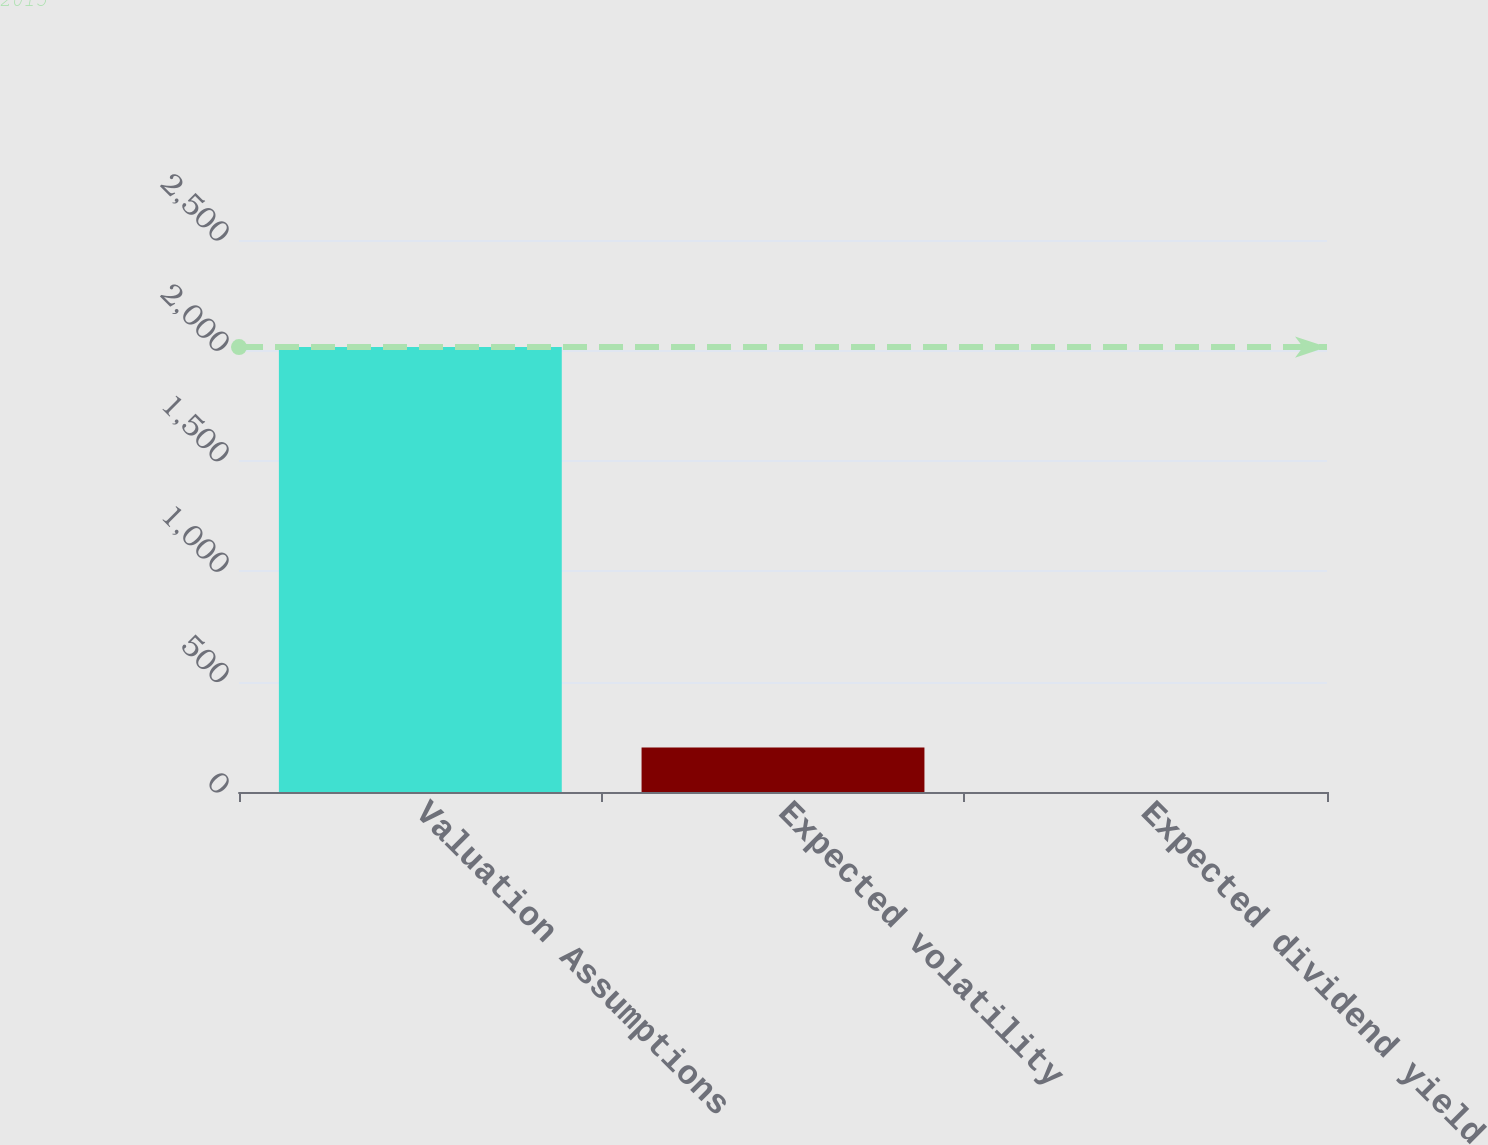Convert chart. <chart><loc_0><loc_0><loc_500><loc_500><bar_chart><fcel>Valuation Assumptions<fcel>Expected volatility<fcel>Expected dividend yield<nl><fcel>2015<fcel>201.57<fcel>0.08<nl></chart> 